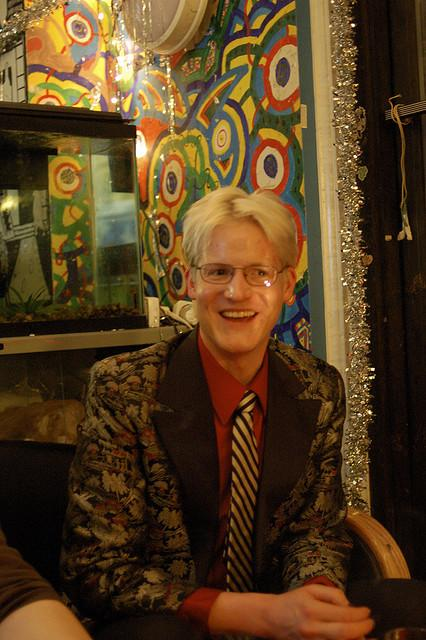What is the gold lining in the doorway called?

Choices:
A) gold leaf
B) tinsel
C) plastic
D) ermine ermine 